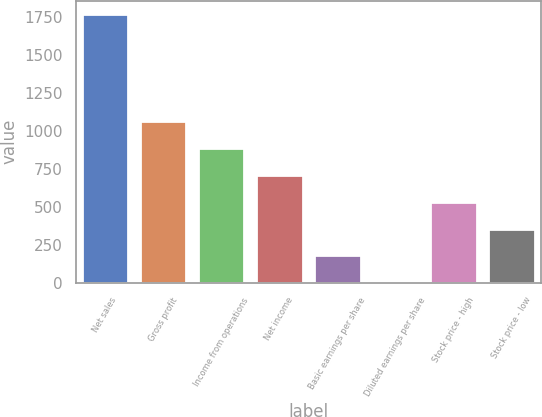<chart> <loc_0><loc_0><loc_500><loc_500><bar_chart><fcel>Net sales<fcel>Gross profit<fcel>Income from operations<fcel>Net income<fcel>Basic earnings per share<fcel>Diluted earnings per share<fcel>Stock price - high<fcel>Stock price - low<nl><fcel>1767.5<fcel>1061.27<fcel>884.72<fcel>708.17<fcel>178.52<fcel>1.97<fcel>531.62<fcel>355.07<nl></chart> 